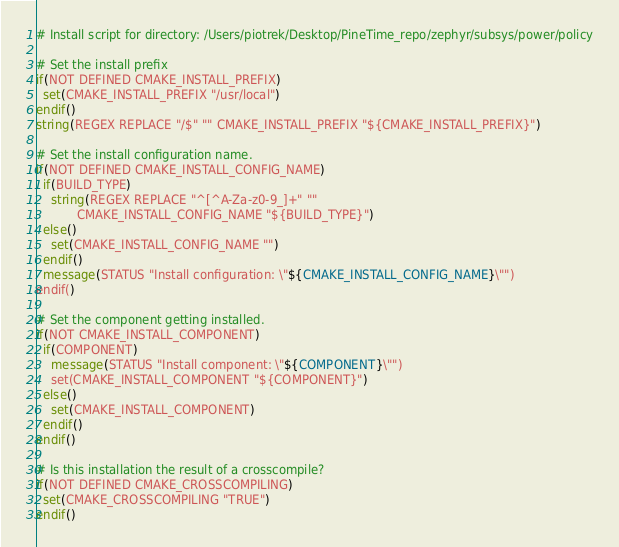Convert code to text. <code><loc_0><loc_0><loc_500><loc_500><_CMake_># Install script for directory: /Users/piotrek/Desktop/PineTime_repo/zephyr/subsys/power/policy

# Set the install prefix
if(NOT DEFINED CMAKE_INSTALL_PREFIX)
  set(CMAKE_INSTALL_PREFIX "/usr/local")
endif()
string(REGEX REPLACE "/$" "" CMAKE_INSTALL_PREFIX "${CMAKE_INSTALL_PREFIX}")

# Set the install configuration name.
if(NOT DEFINED CMAKE_INSTALL_CONFIG_NAME)
  if(BUILD_TYPE)
    string(REGEX REPLACE "^[^A-Za-z0-9_]+" ""
           CMAKE_INSTALL_CONFIG_NAME "${BUILD_TYPE}")
  else()
    set(CMAKE_INSTALL_CONFIG_NAME "")
  endif()
  message(STATUS "Install configuration: \"${CMAKE_INSTALL_CONFIG_NAME}\"")
endif()

# Set the component getting installed.
if(NOT CMAKE_INSTALL_COMPONENT)
  if(COMPONENT)
    message(STATUS "Install component: \"${COMPONENT}\"")
    set(CMAKE_INSTALL_COMPONENT "${COMPONENT}")
  else()
    set(CMAKE_INSTALL_COMPONENT)
  endif()
endif()

# Is this installation the result of a crosscompile?
if(NOT DEFINED CMAKE_CROSSCOMPILING)
  set(CMAKE_CROSSCOMPILING "TRUE")
endif()

</code> 